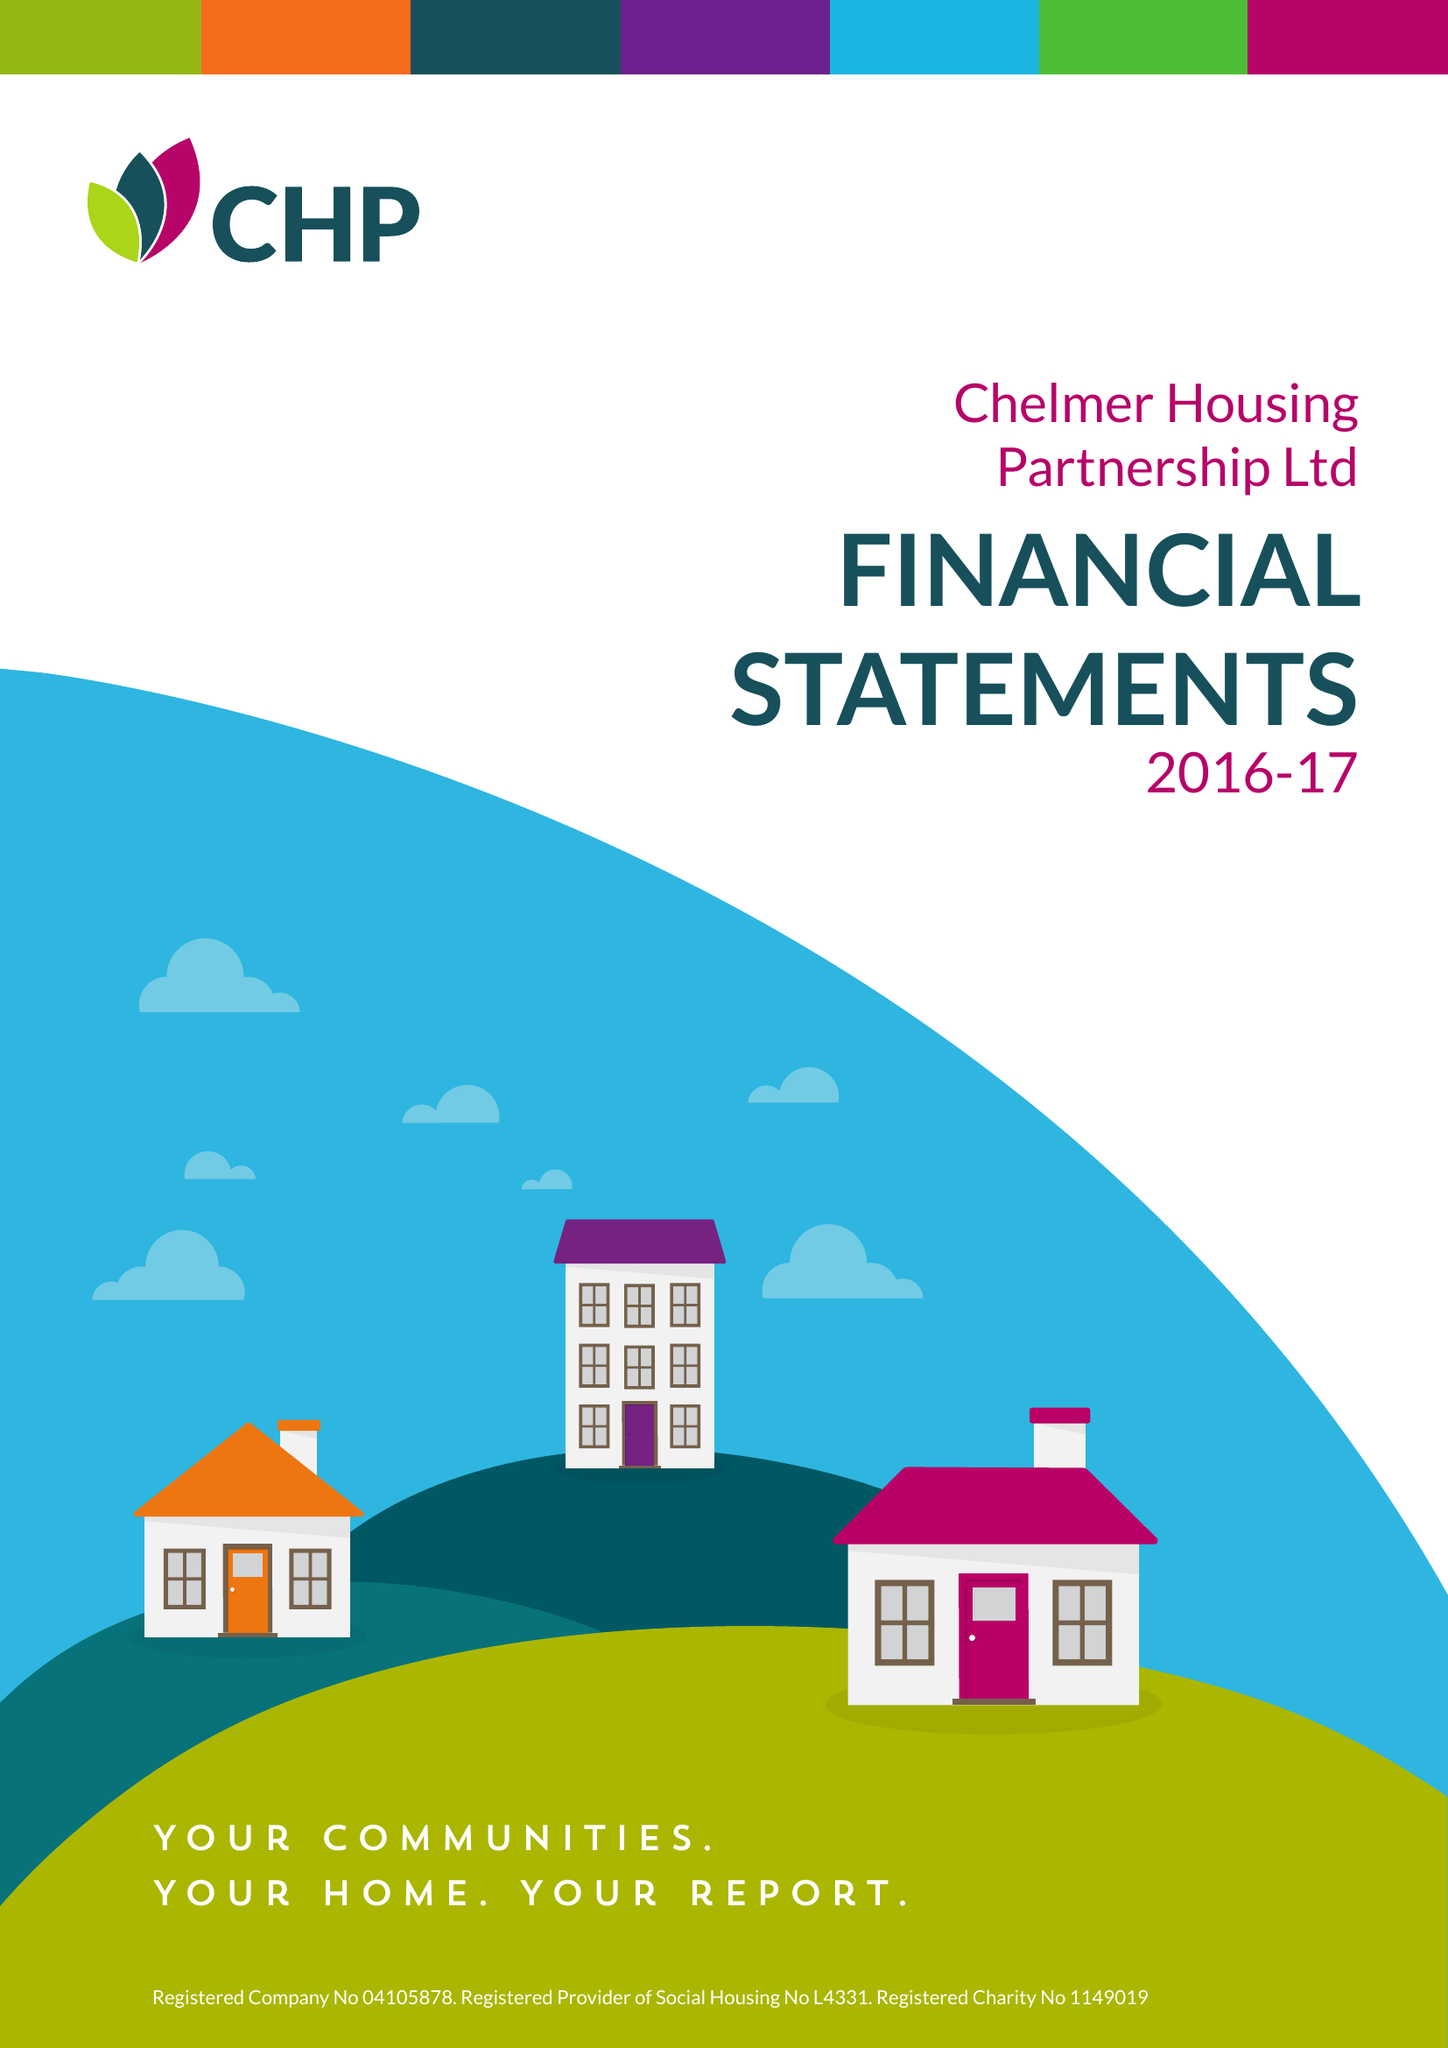What is the value for the charity_number?
Answer the question using a single word or phrase. 1149019 